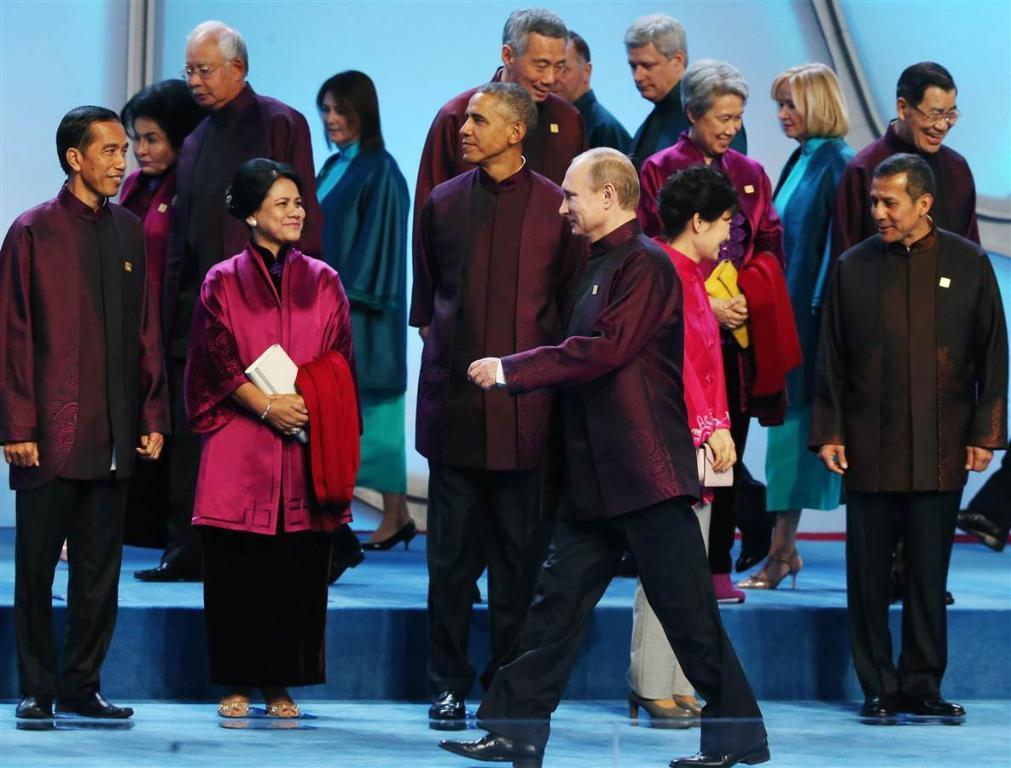How many people are in the image? There is a group of people in the image. What are some of the people doing in the image? Some of the people are standing, some are walking, and some are interacting with each other. What type of rhythm can be heard from the people in the image? There is no audible rhythm in the image, as it is a still photograph. 